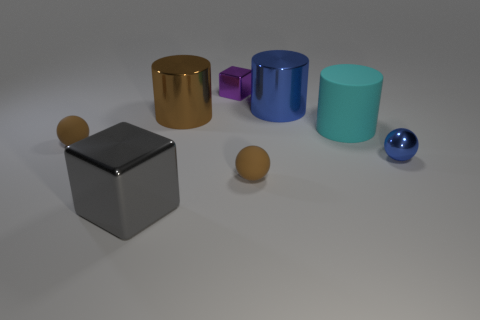Add 1 purple shiny objects. How many objects exist? 9 Subtract all cylinders. How many objects are left? 5 Subtract all blue cylinders. Subtract all rubber things. How many objects are left? 4 Add 1 brown rubber balls. How many brown rubber balls are left? 3 Add 8 cyan matte cubes. How many cyan matte cubes exist? 8 Subtract 0 blue blocks. How many objects are left? 8 